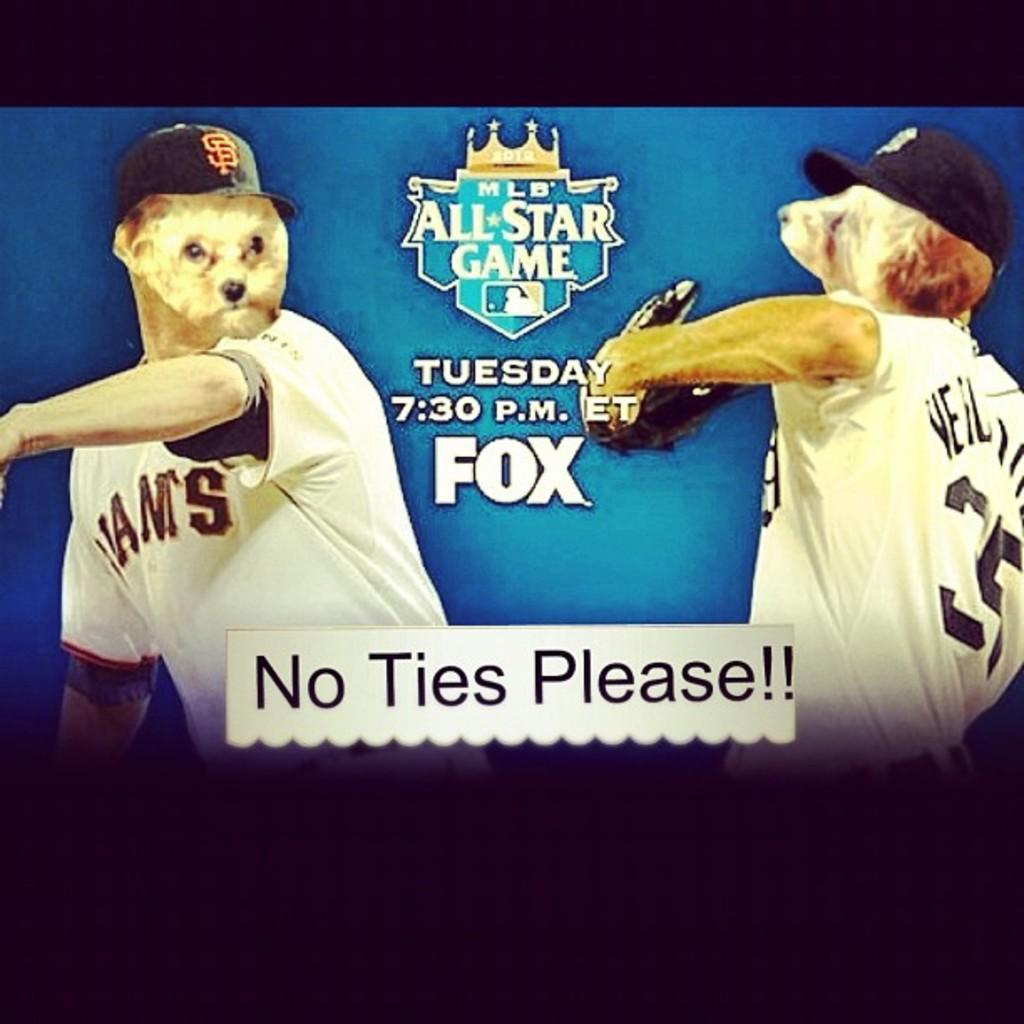<image>
Give a short and clear explanation of the subsequent image. The game being advertised will be shown on Fox network. 